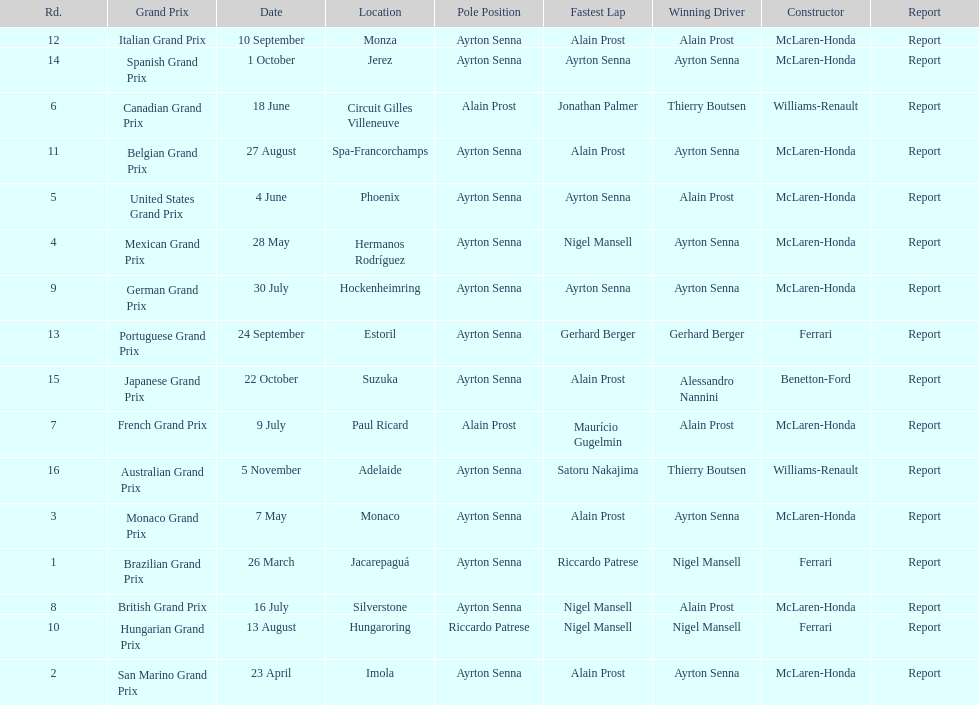Who had the fastest lap at the german grand prix? Ayrton Senna. 